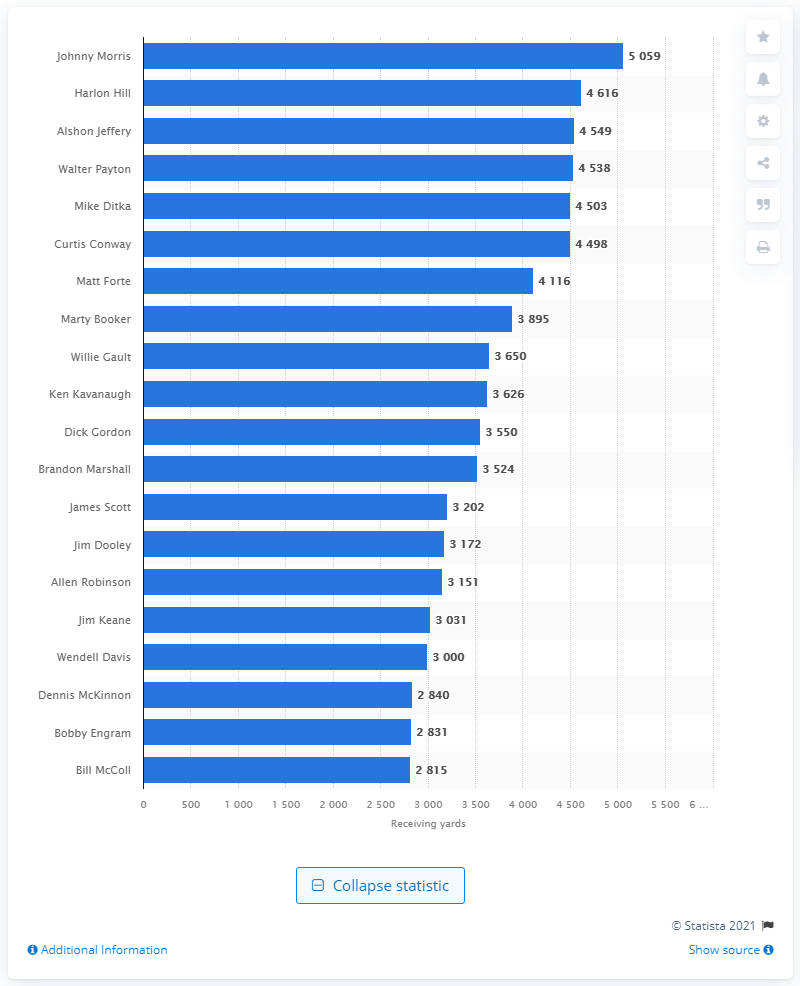List a handful of essential elements in this visual. Johnny Morris is the all-time career receiving leader for the Chicago Bears. 